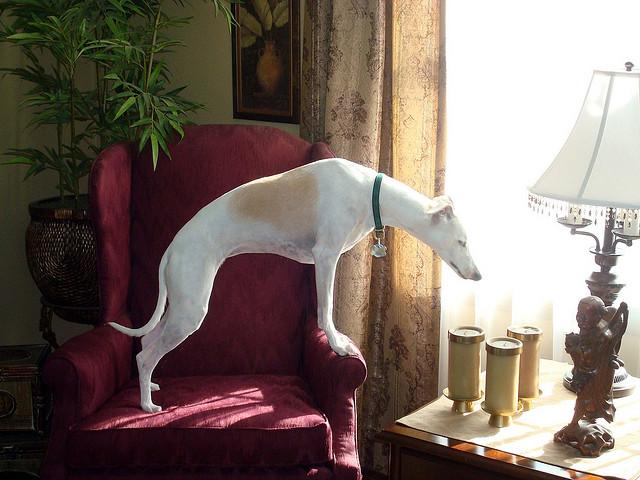What color is the chair?
Be succinct. Red. What kind of light is on table?
Answer briefly. Lamp. What color is the dog's collar?
Answer briefly. Green. What is the dog standing near?
Short answer required. Window. What color is the dog?
Short answer required. White. Is this dog wanting to drink from the cups?
Short answer required. No. What breed of dog is this?
Be succinct. Greyhound. 